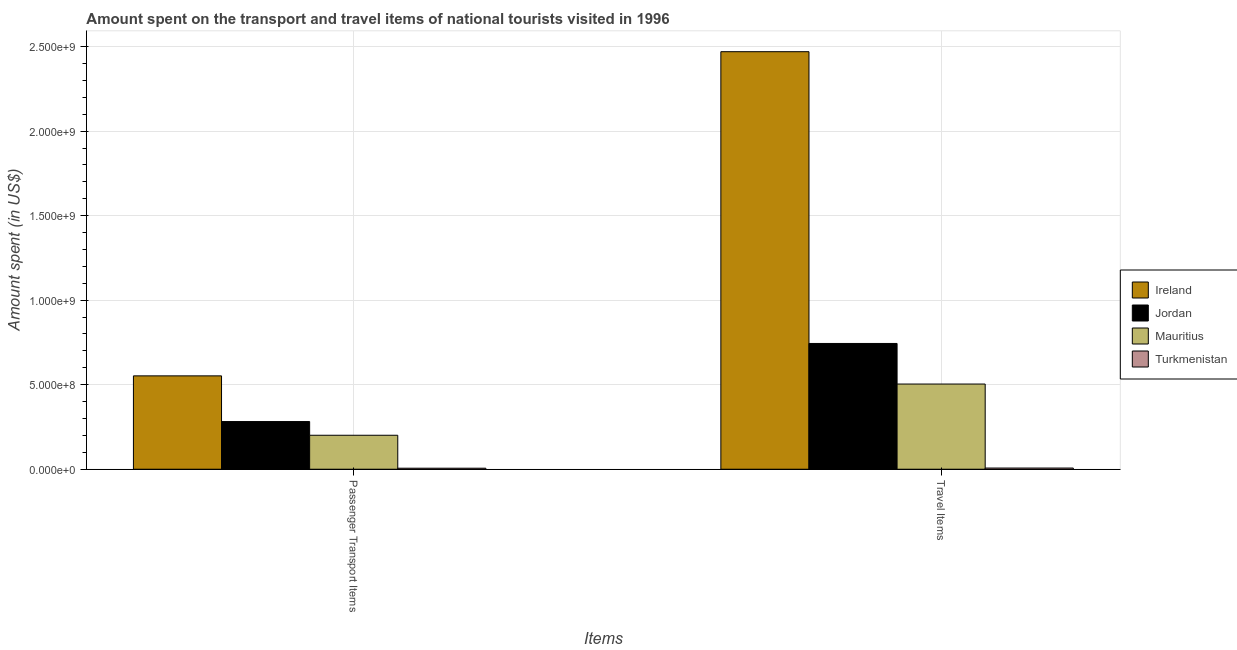Are the number of bars on each tick of the X-axis equal?
Make the answer very short. Yes. What is the label of the 2nd group of bars from the left?
Ensure brevity in your answer.  Travel Items. What is the amount spent in travel items in Ireland?
Give a very brief answer. 2.47e+09. Across all countries, what is the maximum amount spent in travel items?
Ensure brevity in your answer.  2.47e+09. Across all countries, what is the minimum amount spent in travel items?
Your response must be concise. 7.00e+06. In which country was the amount spent on passenger transport items maximum?
Your answer should be very brief. Ireland. In which country was the amount spent in travel items minimum?
Provide a short and direct response. Turkmenistan. What is the total amount spent in travel items in the graph?
Provide a short and direct response. 3.72e+09. What is the difference between the amount spent in travel items in Mauritius and that in Turkmenistan?
Give a very brief answer. 4.97e+08. What is the difference between the amount spent in travel items in Turkmenistan and the amount spent on passenger transport items in Jordan?
Make the answer very short. -2.75e+08. What is the average amount spent on passenger transport items per country?
Offer a terse response. 2.60e+08. What is the difference between the amount spent in travel items and amount spent on passenger transport items in Ireland?
Give a very brief answer. 1.92e+09. In how many countries, is the amount spent on passenger transport items greater than 1500000000 US$?
Make the answer very short. 0. What is the ratio of the amount spent on passenger transport items in Turkmenistan to that in Ireland?
Your answer should be compact. 0.01. Is the amount spent on passenger transport items in Jordan less than that in Mauritius?
Give a very brief answer. No. In how many countries, is the amount spent in travel items greater than the average amount spent in travel items taken over all countries?
Offer a terse response. 1. What does the 2nd bar from the left in Passenger Transport Items represents?
Give a very brief answer. Jordan. What does the 2nd bar from the right in Passenger Transport Items represents?
Your answer should be compact. Mauritius. How many bars are there?
Your answer should be very brief. 8. Are all the bars in the graph horizontal?
Provide a short and direct response. No. Are the values on the major ticks of Y-axis written in scientific E-notation?
Your answer should be compact. Yes. How many legend labels are there?
Your answer should be compact. 4. What is the title of the graph?
Offer a terse response. Amount spent on the transport and travel items of national tourists visited in 1996. What is the label or title of the X-axis?
Keep it short and to the point. Items. What is the label or title of the Y-axis?
Make the answer very short. Amount spent (in US$). What is the Amount spent (in US$) in Ireland in Passenger Transport Items?
Keep it short and to the point. 5.52e+08. What is the Amount spent (in US$) of Jordan in Passenger Transport Items?
Make the answer very short. 2.82e+08. What is the Amount spent (in US$) in Mauritius in Passenger Transport Items?
Give a very brief answer. 2.01e+08. What is the Amount spent (in US$) of Ireland in Travel Items?
Offer a terse response. 2.47e+09. What is the Amount spent (in US$) of Jordan in Travel Items?
Your response must be concise. 7.44e+08. What is the Amount spent (in US$) of Mauritius in Travel Items?
Make the answer very short. 5.04e+08. Across all Items, what is the maximum Amount spent (in US$) of Ireland?
Keep it short and to the point. 2.47e+09. Across all Items, what is the maximum Amount spent (in US$) in Jordan?
Keep it short and to the point. 7.44e+08. Across all Items, what is the maximum Amount spent (in US$) in Mauritius?
Keep it short and to the point. 5.04e+08. Across all Items, what is the minimum Amount spent (in US$) of Ireland?
Your answer should be very brief. 5.52e+08. Across all Items, what is the minimum Amount spent (in US$) of Jordan?
Provide a succinct answer. 2.82e+08. Across all Items, what is the minimum Amount spent (in US$) of Mauritius?
Offer a terse response. 2.01e+08. What is the total Amount spent (in US$) of Ireland in the graph?
Offer a very short reply. 3.02e+09. What is the total Amount spent (in US$) in Jordan in the graph?
Your answer should be compact. 1.03e+09. What is the total Amount spent (in US$) of Mauritius in the graph?
Offer a terse response. 7.05e+08. What is the total Amount spent (in US$) in Turkmenistan in the graph?
Provide a short and direct response. 1.30e+07. What is the difference between the Amount spent (in US$) in Ireland in Passenger Transport Items and that in Travel Items?
Provide a short and direct response. -1.92e+09. What is the difference between the Amount spent (in US$) of Jordan in Passenger Transport Items and that in Travel Items?
Your answer should be very brief. -4.62e+08. What is the difference between the Amount spent (in US$) in Mauritius in Passenger Transport Items and that in Travel Items?
Provide a succinct answer. -3.03e+08. What is the difference between the Amount spent (in US$) of Turkmenistan in Passenger Transport Items and that in Travel Items?
Keep it short and to the point. -1.00e+06. What is the difference between the Amount spent (in US$) in Ireland in Passenger Transport Items and the Amount spent (in US$) in Jordan in Travel Items?
Ensure brevity in your answer.  -1.92e+08. What is the difference between the Amount spent (in US$) in Ireland in Passenger Transport Items and the Amount spent (in US$) in Mauritius in Travel Items?
Keep it short and to the point. 4.83e+07. What is the difference between the Amount spent (in US$) of Ireland in Passenger Transport Items and the Amount spent (in US$) of Turkmenistan in Travel Items?
Give a very brief answer. 5.45e+08. What is the difference between the Amount spent (in US$) in Jordan in Passenger Transport Items and the Amount spent (in US$) in Mauritius in Travel Items?
Provide a short and direct response. -2.22e+08. What is the difference between the Amount spent (in US$) of Jordan in Passenger Transport Items and the Amount spent (in US$) of Turkmenistan in Travel Items?
Your response must be concise. 2.75e+08. What is the difference between the Amount spent (in US$) of Mauritius in Passenger Transport Items and the Amount spent (in US$) of Turkmenistan in Travel Items?
Offer a very short reply. 1.94e+08. What is the average Amount spent (in US$) in Ireland per Items?
Give a very brief answer. 1.51e+09. What is the average Amount spent (in US$) in Jordan per Items?
Give a very brief answer. 5.13e+08. What is the average Amount spent (in US$) of Mauritius per Items?
Keep it short and to the point. 3.52e+08. What is the average Amount spent (in US$) of Turkmenistan per Items?
Provide a succinct answer. 6.50e+06. What is the difference between the Amount spent (in US$) in Ireland and Amount spent (in US$) in Jordan in Passenger Transport Items?
Provide a succinct answer. 2.70e+08. What is the difference between the Amount spent (in US$) in Ireland and Amount spent (in US$) in Mauritius in Passenger Transport Items?
Keep it short and to the point. 3.51e+08. What is the difference between the Amount spent (in US$) in Ireland and Amount spent (in US$) in Turkmenistan in Passenger Transport Items?
Your answer should be very brief. 5.46e+08. What is the difference between the Amount spent (in US$) of Jordan and Amount spent (in US$) of Mauritius in Passenger Transport Items?
Your answer should be very brief. 8.10e+07. What is the difference between the Amount spent (in US$) in Jordan and Amount spent (in US$) in Turkmenistan in Passenger Transport Items?
Your answer should be very brief. 2.76e+08. What is the difference between the Amount spent (in US$) of Mauritius and Amount spent (in US$) of Turkmenistan in Passenger Transport Items?
Give a very brief answer. 1.95e+08. What is the difference between the Amount spent (in US$) in Ireland and Amount spent (in US$) in Jordan in Travel Items?
Ensure brevity in your answer.  1.73e+09. What is the difference between the Amount spent (in US$) of Ireland and Amount spent (in US$) of Mauritius in Travel Items?
Keep it short and to the point. 1.97e+09. What is the difference between the Amount spent (in US$) in Ireland and Amount spent (in US$) in Turkmenistan in Travel Items?
Keep it short and to the point. 2.46e+09. What is the difference between the Amount spent (in US$) of Jordan and Amount spent (in US$) of Mauritius in Travel Items?
Your response must be concise. 2.40e+08. What is the difference between the Amount spent (in US$) in Jordan and Amount spent (in US$) in Turkmenistan in Travel Items?
Provide a succinct answer. 7.37e+08. What is the difference between the Amount spent (in US$) in Mauritius and Amount spent (in US$) in Turkmenistan in Travel Items?
Ensure brevity in your answer.  4.97e+08. What is the ratio of the Amount spent (in US$) in Ireland in Passenger Transport Items to that in Travel Items?
Give a very brief answer. 0.22. What is the ratio of the Amount spent (in US$) of Jordan in Passenger Transport Items to that in Travel Items?
Your answer should be very brief. 0.38. What is the ratio of the Amount spent (in US$) in Mauritius in Passenger Transport Items to that in Travel Items?
Your response must be concise. 0.4. What is the difference between the highest and the second highest Amount spent (in US$) in Ireland?
Give a very brief answer. 1.92e+09. What is the difference between the highest and the second highest Amount spent (in US$) in Jordan?
Offer a terse response. 4.62e+08. What is the difference between the highest and the second highest Amount spent (in US$) in Mauritius?
Provide a short and direct response. 3.03e+08. What is the difference between the highest and the second highest Amount spent (in US$) of Turkmenistan?
Provide a succinct answer. 1.00e+06. What is the difference between the highest and the lowest Amount spent (in US$) in Ireland?
Provide a short and direct response. 1.92e+09. What is the difference between the highest and the lowest Amount spent (in US$) in Jordan?
Keep it short and to the point. 4.62e+08. What is the difference between the highest and the lowest Amount spent (in US$) in Mauritius?
Your answer should be compact. 3.03e+08. What is the difference between the highest and the lowest Amount spent (in US$) of Turkmenistan?
Ensure brevity in your answer.  1.00e+06. 